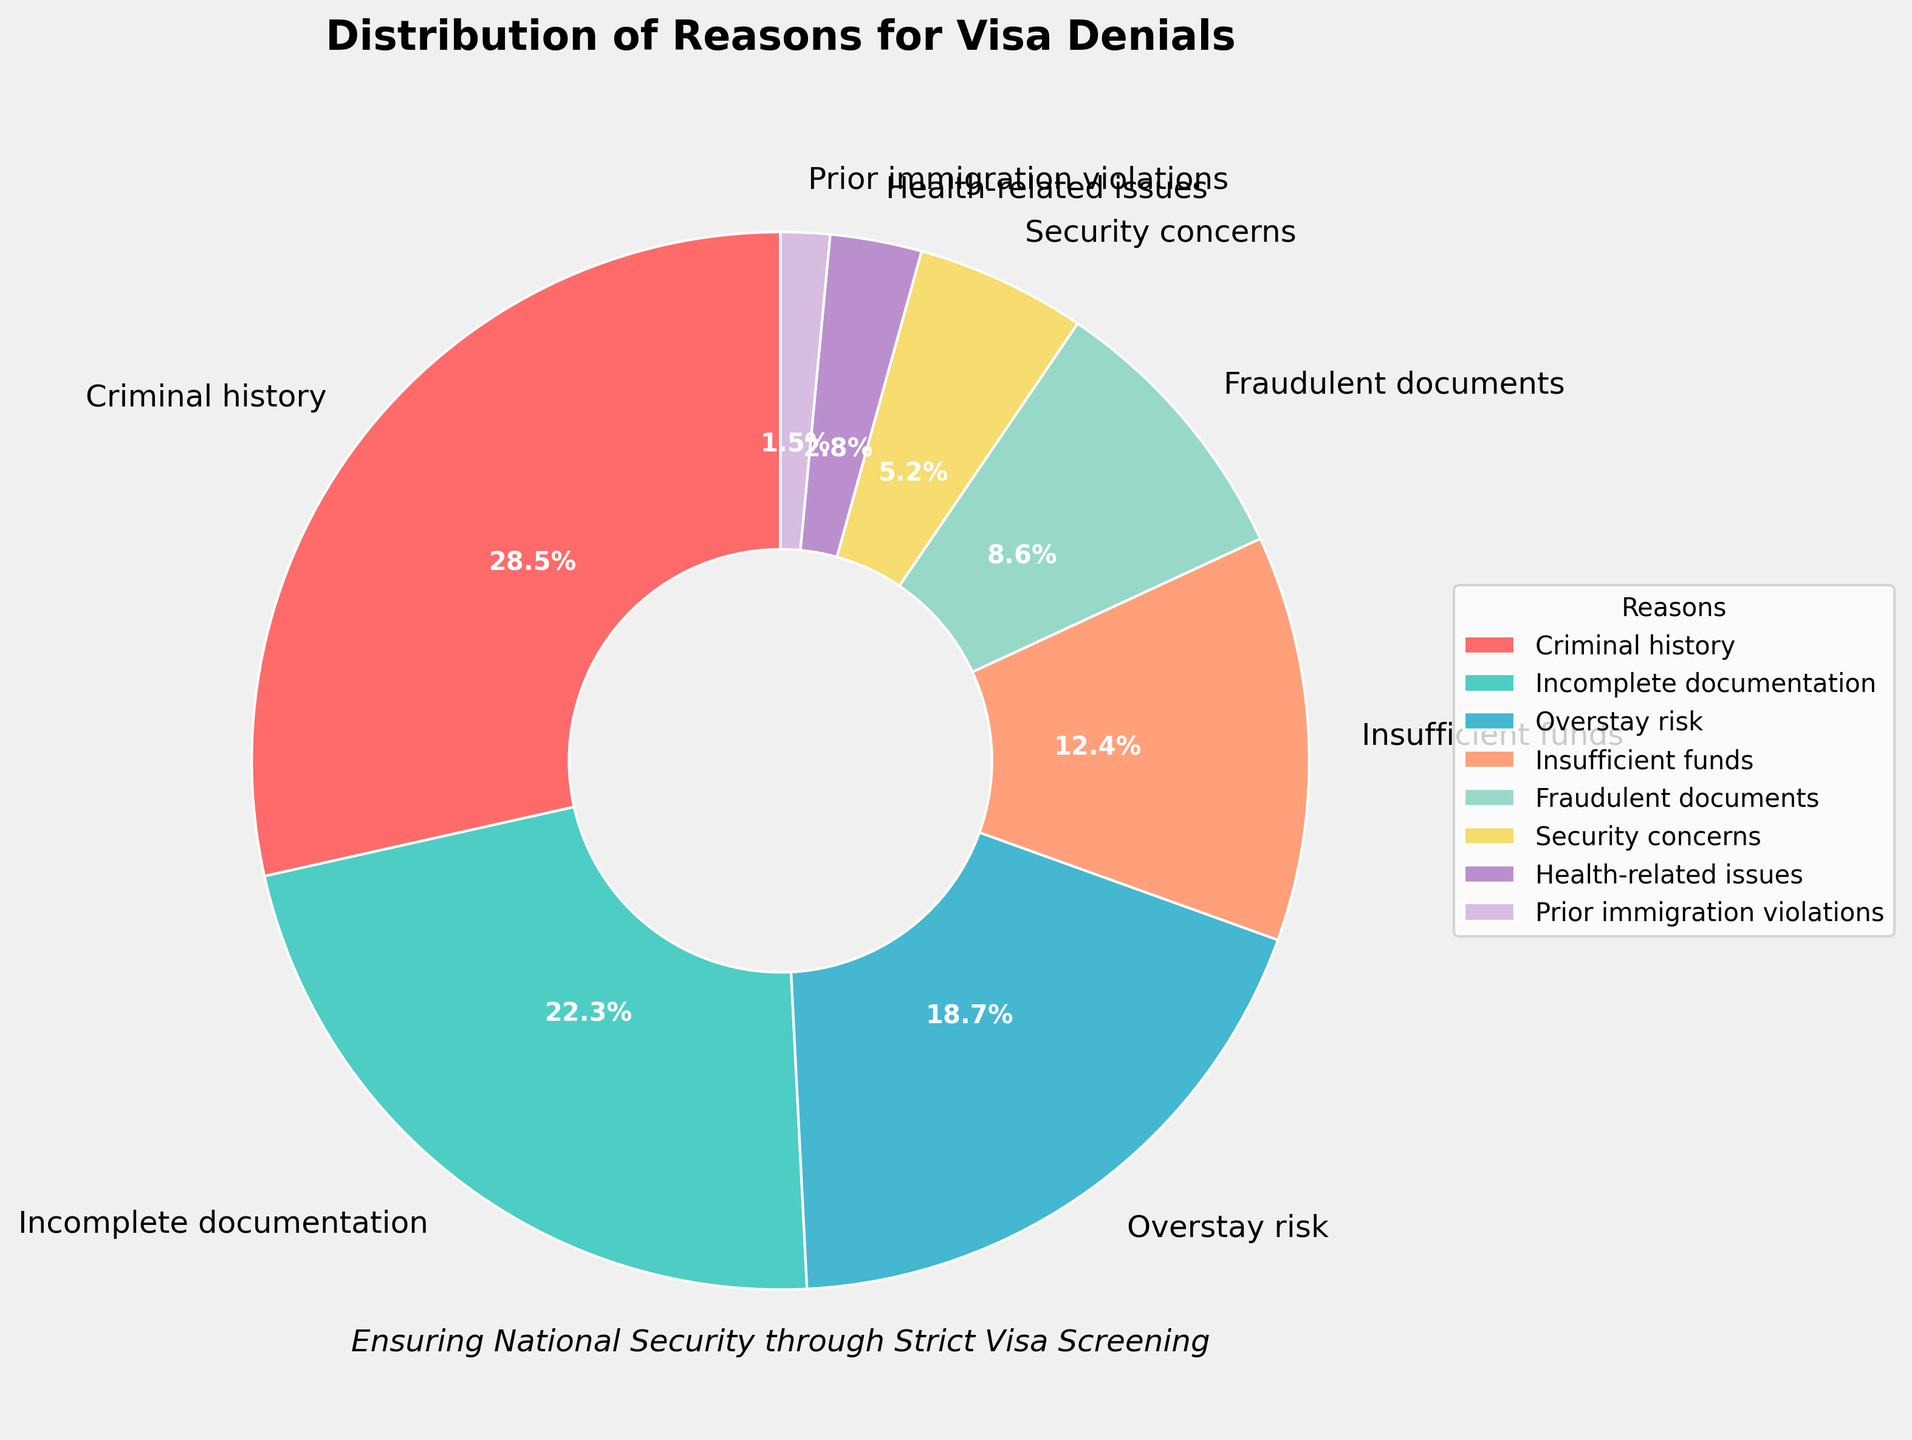Which reason accounts for the largest percentage of visa denials? Look at the pie chart and find the segment with the largest size. The label "Criminal history" is associated with the largest segment, which is 28.5%.
Answer: Criminal history What percentage of visa denials is due to health-related issues and prior immigration violations combined? Find the percentages for health-related issues (2.8%) and prior immigration violations (1.5%) and add them together. 2.8% + 1.5% = 4.3%.
Answer: 4.3% Compare the percentages of visa denials due to fraudulent documents and security concerns. Which is greater? Identify the percentages for fraudulent documents (8.6%) and security concerns (5.2%) and compare them. 8.6% is greater than 5.2%.
Answer: Fraudulent documents Which reason has the smallest percentage of visa denials and what is that percentage? Look at the pie chart and identify the smallest segment. The label "Prior immigration violations" corresponds to the smallest segment with 1.5%.
Answer: Prior immigration violations, 1.5% How much more significant (in percentage points) is the reason of incomplete documentation compared to overstay risk? Subtract the percentage of overstay risk (18.7%) from the percentage of incomplete documentation (22.3%). 22.3% - 18.7% = 3.6%.
Answer: 3.6% If we only consider reasons with a percentage less than 10%, what is their total combined percentage? Identify the reasons with percentages less than 10%: Fraudulent documents (8.6%), Security concerns (5.2%), Health-related issues (2.8%), and Prior immigration violations (1.5%). Add these up: 8.6% + 5.2% + 2.8% + 1.5% = 18.1%.
Answer: 18.1% What is the second most common reason for visa denials and its corresponding percentage? After identifying the reason with the highest percentage (Criminal history at 28.5%), find the next largest segment which is "Incomplete documentation" at 22.3%.
Answer: Incomplete documentation, 22.3% What is the difference in percentage points between insufficient funds and fraud-related denials? Subtract the percentage of fraudulent documents (8.6%) from insufficient funds (12.4%). 12.4% - 8.6% = 3.8%.
Answer: 3.8% What color represents the segment for overstay risk? Look at the pie chart and locate the label "Overstay risk," then identify the color associated with that segment. Overstay risk is represented by a shade of blue.
Answer: Blue What percentage of visa denials are not due to criminal history, incomplete documentation, or overstay risk? Find the percentages of the top three reasons: Criminal history (28.5%), Incomplete documentation (22.3%), and Overstay risk (18.7%). Add them together and subtract from 100%: 100% - (28.5% + 22.3% + 18.7%) = 30.5%.
Answer: 30.5% 